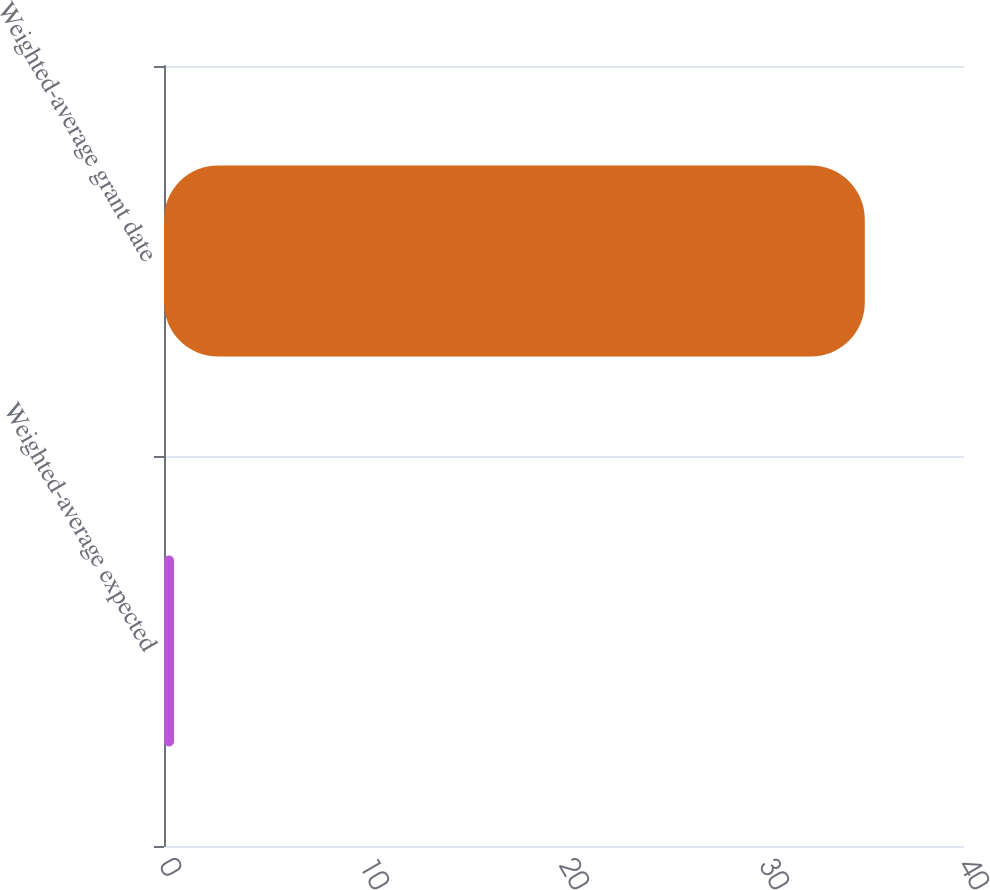Convert chart to OTSL. <chart><loc_0><loc_0><loc_500><loc_500><bar_chart><fcel>Weighted-average expected<fcel>Weighted-average grant date<nl><fcel>0.5<fcel>35.04<nl></chart> 